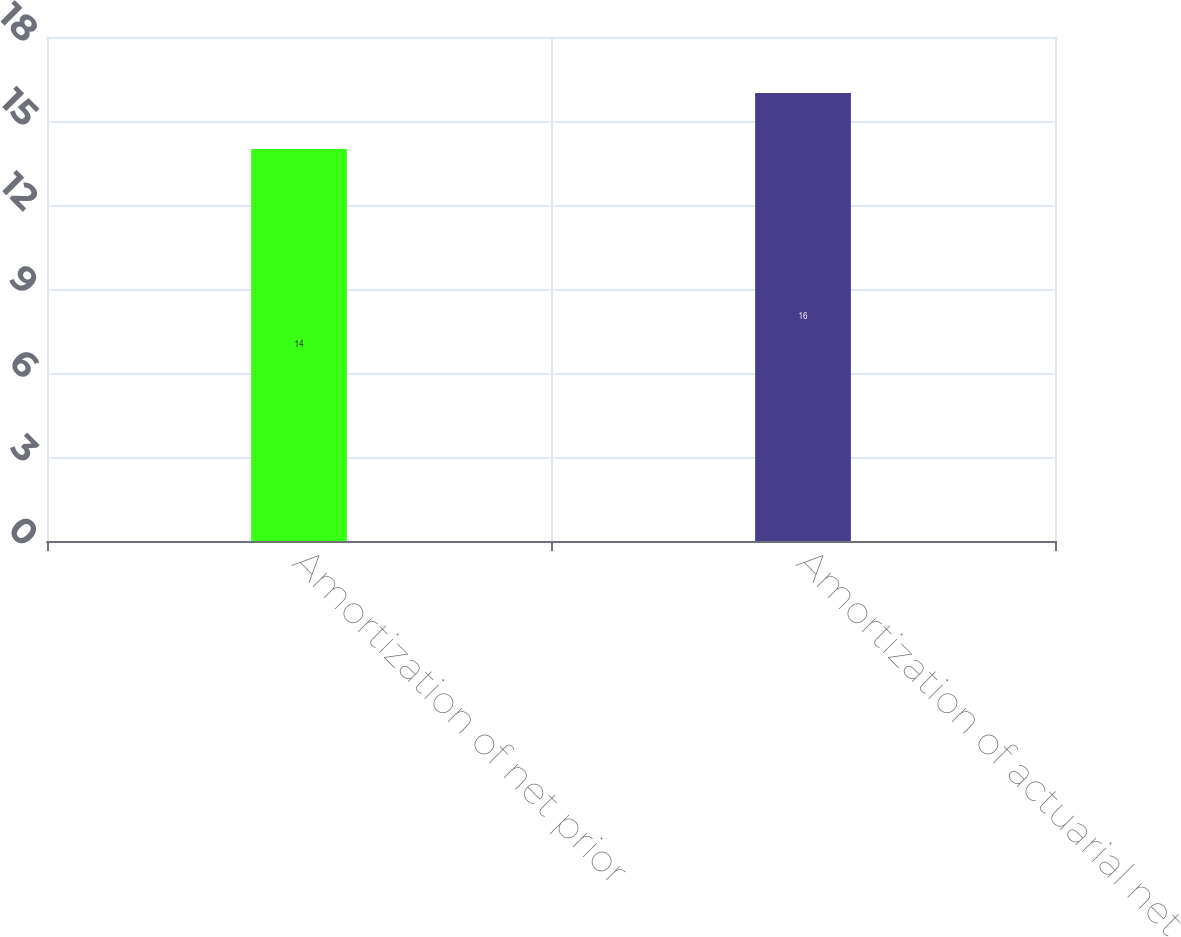Convert chart. <chart><loc_0><loc_0><loc_500><loc_500><bar_chart><fcel>Amortization of net prior<fcel>Amortization of actuarial net<nl><fcel>14<fcel>16<nl></chart> 